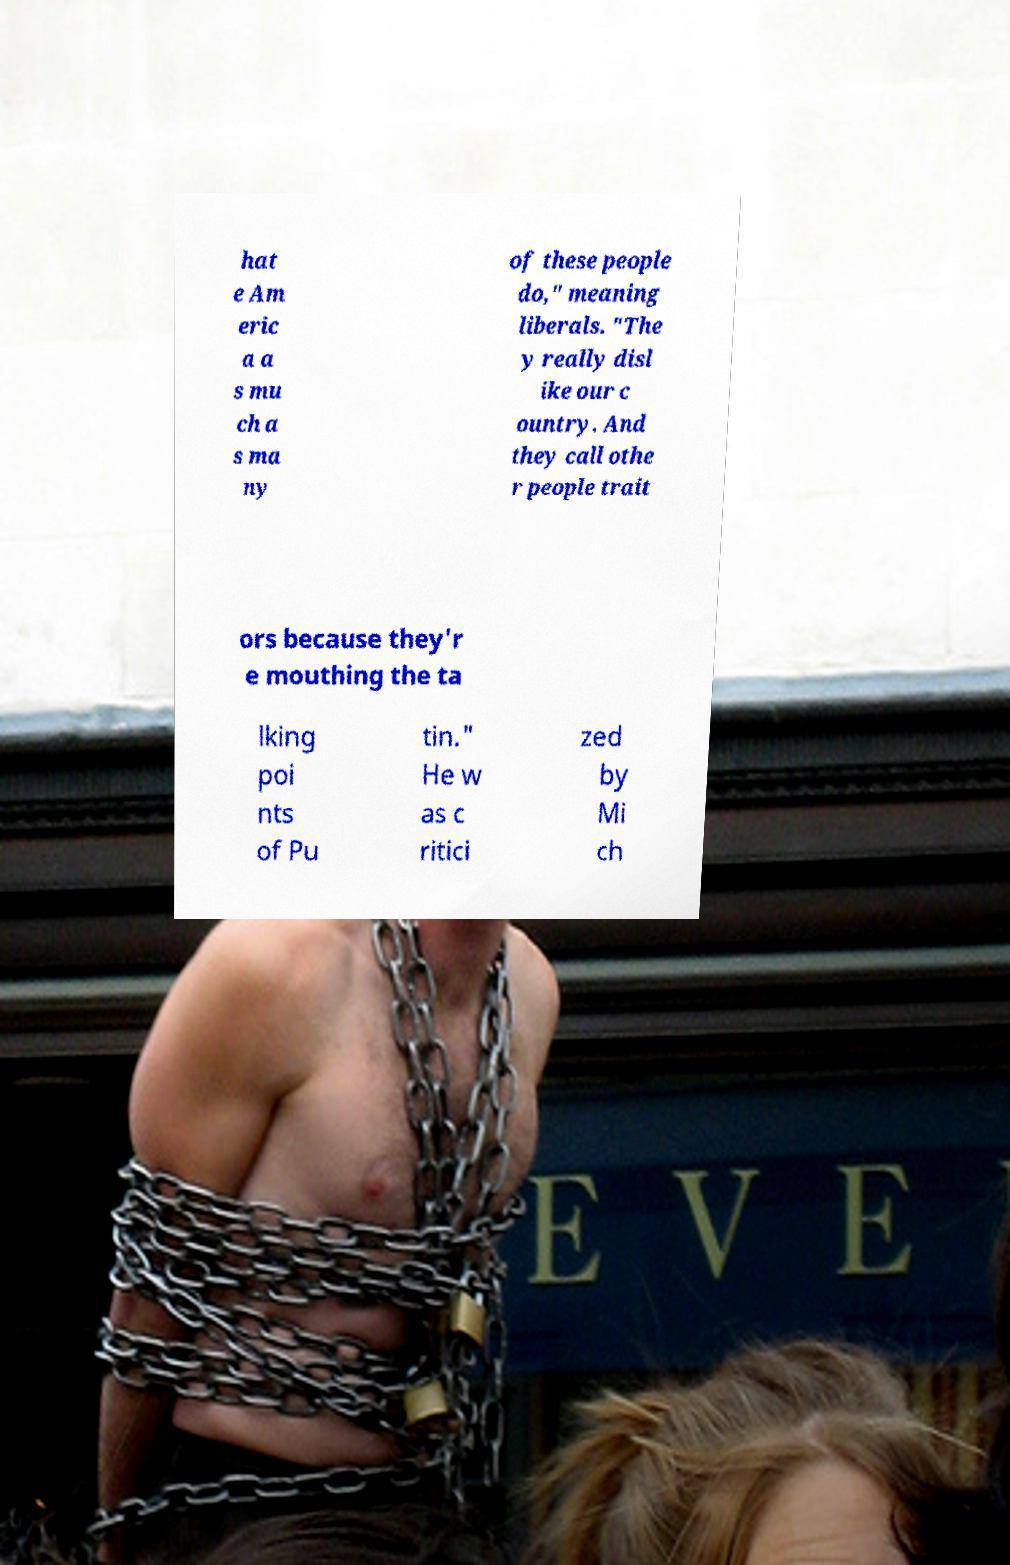Could you extract and type out the text from this image? hat e Am eric a a s mu ch a s ma ny of these people do," meaning liberals. "The y really disl ike our c ountry. And they call othe r people trait ors because they'r e mouthing the ta lking poi nts of Pu tin." He w as c ritici zed by Mi ch 